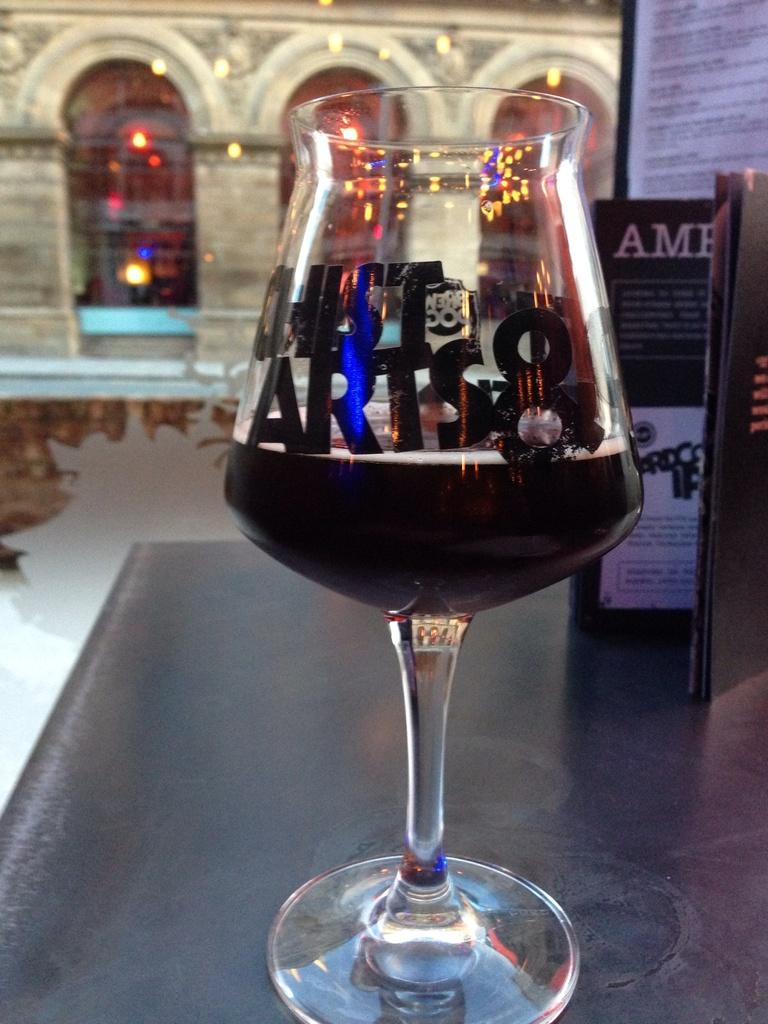What is contained in the glass that is visible in the image? There is a glass with liquid in the image. What else can be seen in the image besides the glass? There is a book and a board visible in the image. What is visible in the background of the image? There is a building visible in the background of the image. Can you tell me how many cherries are on the board in the image? There are no cherries present in the image; the board is the only item mentioned in the facts. What type of bridge can be seen connecting the building in the background? There is no bridge visible in the image; only a building is mentioned in the background. 